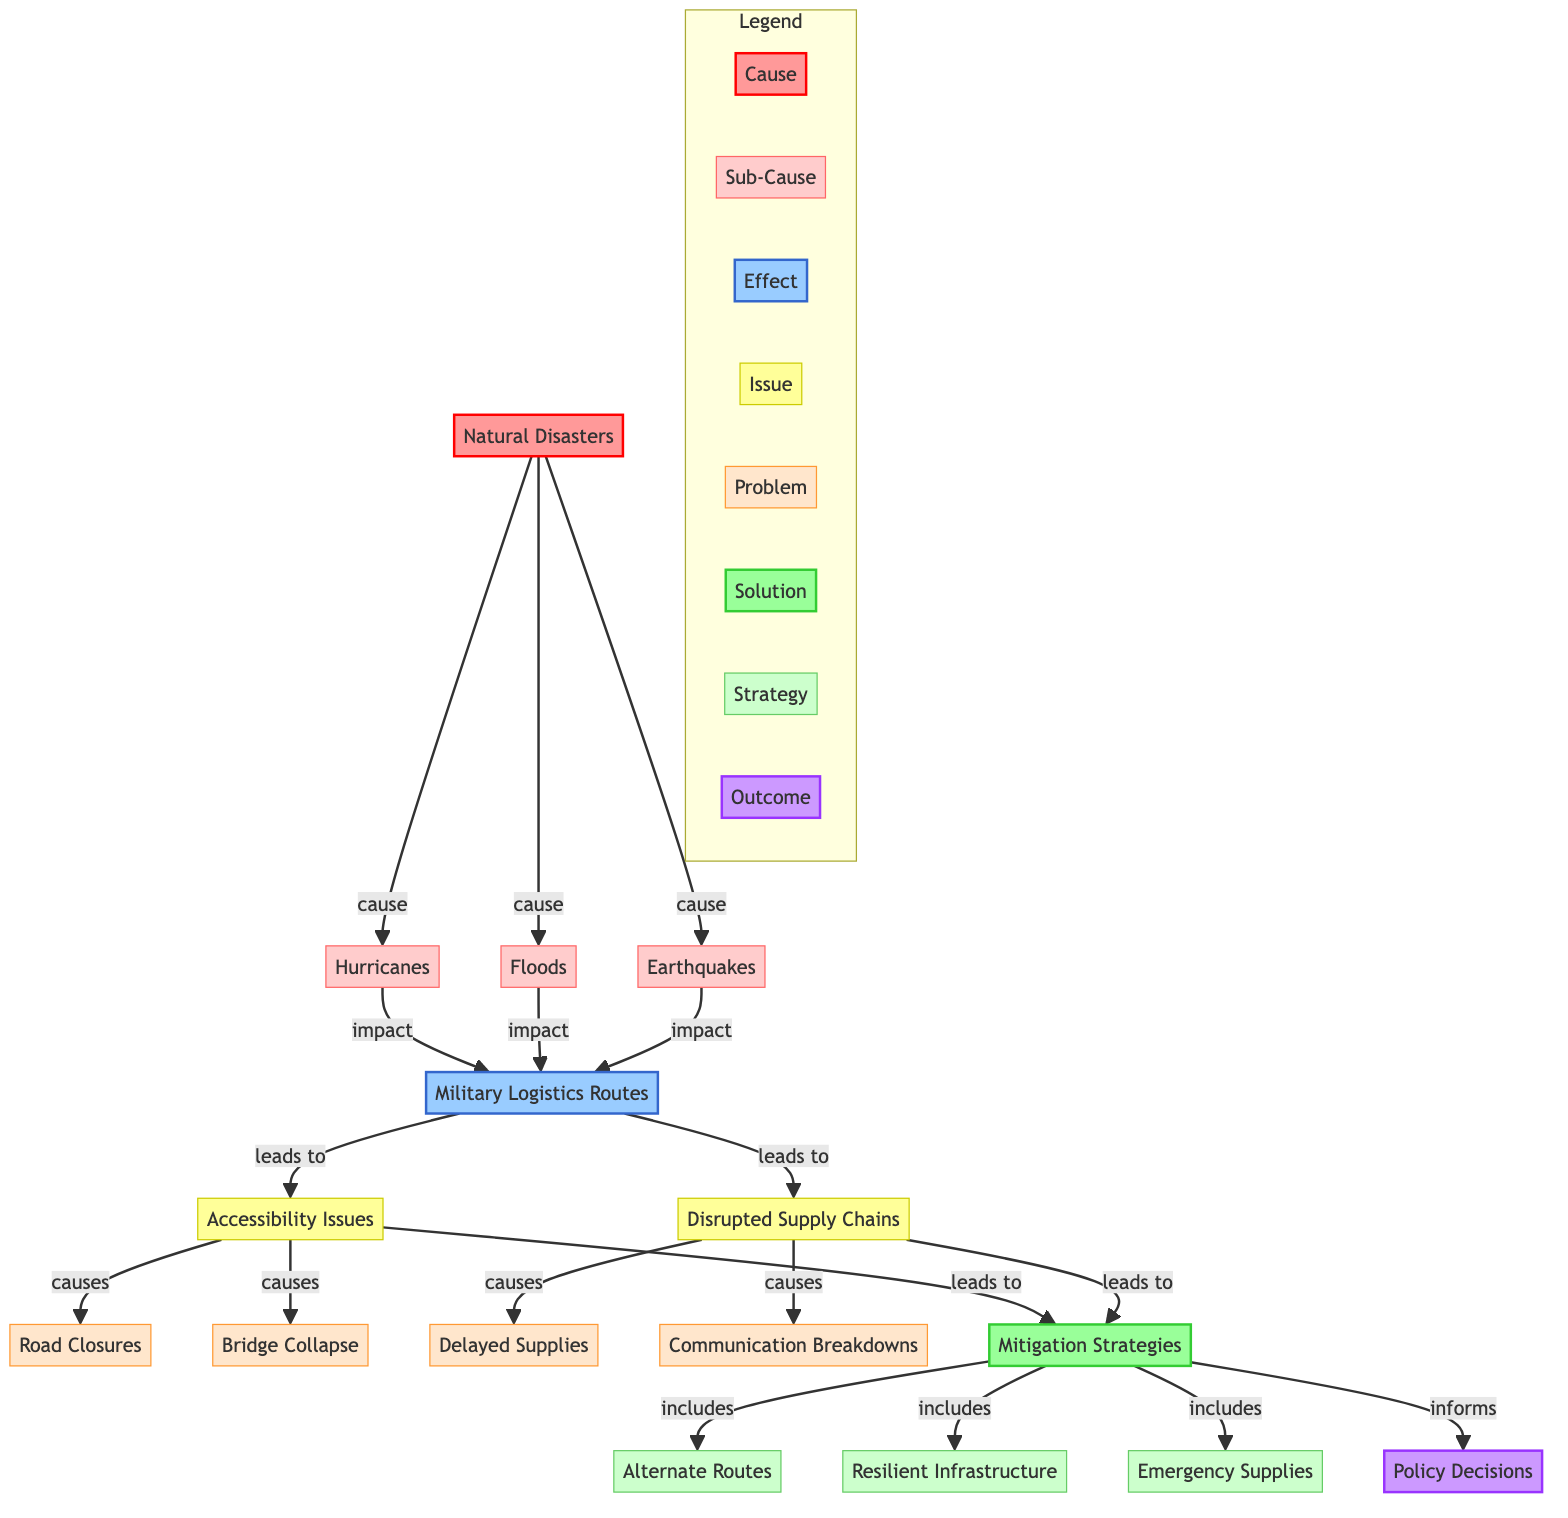What are the three main types of natural disasters listed? The diagram identifies three main types of natural disasters: Hurricanes, Floods, and Earthquakes, which are all connected to the node "Natural Disasters."
Answer: Hurricanes, Floods, Earthquakes What issues arise from military logistics routes? The diagram indicates two main issues that arise from military logistics routes: Accessibility Issues and Disrupted Supply Chains.
Answer: Accessibility Issues, Disrupted Supply Chains What are the consequences of accessibility issues? According to the diagram, accessibility issues lead to two specific problems: Road Closures and Bridge Collapse.
Answer: Road Closures, Bridge Collapse What solutions are proposed in the diagram? The diagram lists three solutions to the problems caused by natural disasters impacting military logistics: Alternate Routes, Resilient Infrastructure, and Emergency Supplies.
Answer: Alternate Routes, Resilient Infrastructure, Emergency Supplies What leads to communication breakdowns? The diagram shows that Disrupted Supply Chains result in communication breakdowns, indicating a direct relationship between these two nodes.
Answer: Disrupted Supply Chains How many types of natural disasters lead to impacts on military logistics routes? The diagram connects one cause, "Natural Disasters," to three sub-causes: Hurricanes, Floods, and Earthquakes. Therefore, three types of natural disasters lead to impacts.
Answer: Three What are the issues linked to disrupted supply chains? The diagram indicates that Disrupted Supply Chains cause Delayed Supplies and Communication Breakdowns, which are both connected directly to the "Disrupted Supply Chains" node.
Answer: Delayed Supplies, Communication Breakdowns What is the final outcome informed by mitigation strategies? The diagram specifies that the mitigation strategies inform Policy Decisions, establishing a direct pathway from solutions to outcomes.
Answer: Policy Decisions Which mitigation strategy specifically involves infrastructure? The diagram highlights "Resilient Infrastructure" as a mitigation strategy that directly addresses the issues caused by natural disasters affecting logistics.
Answer: Resilient Infrastructure 